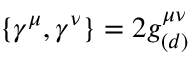Convert formula to latex. <formula><loc_0><loc_0><loc_500><loc_500>\{ \gamma ^ { \mu } , \gamma ^ { \nu } \} = 2 g _ { ( d ) } ^ { \mu \nu }</formula> 